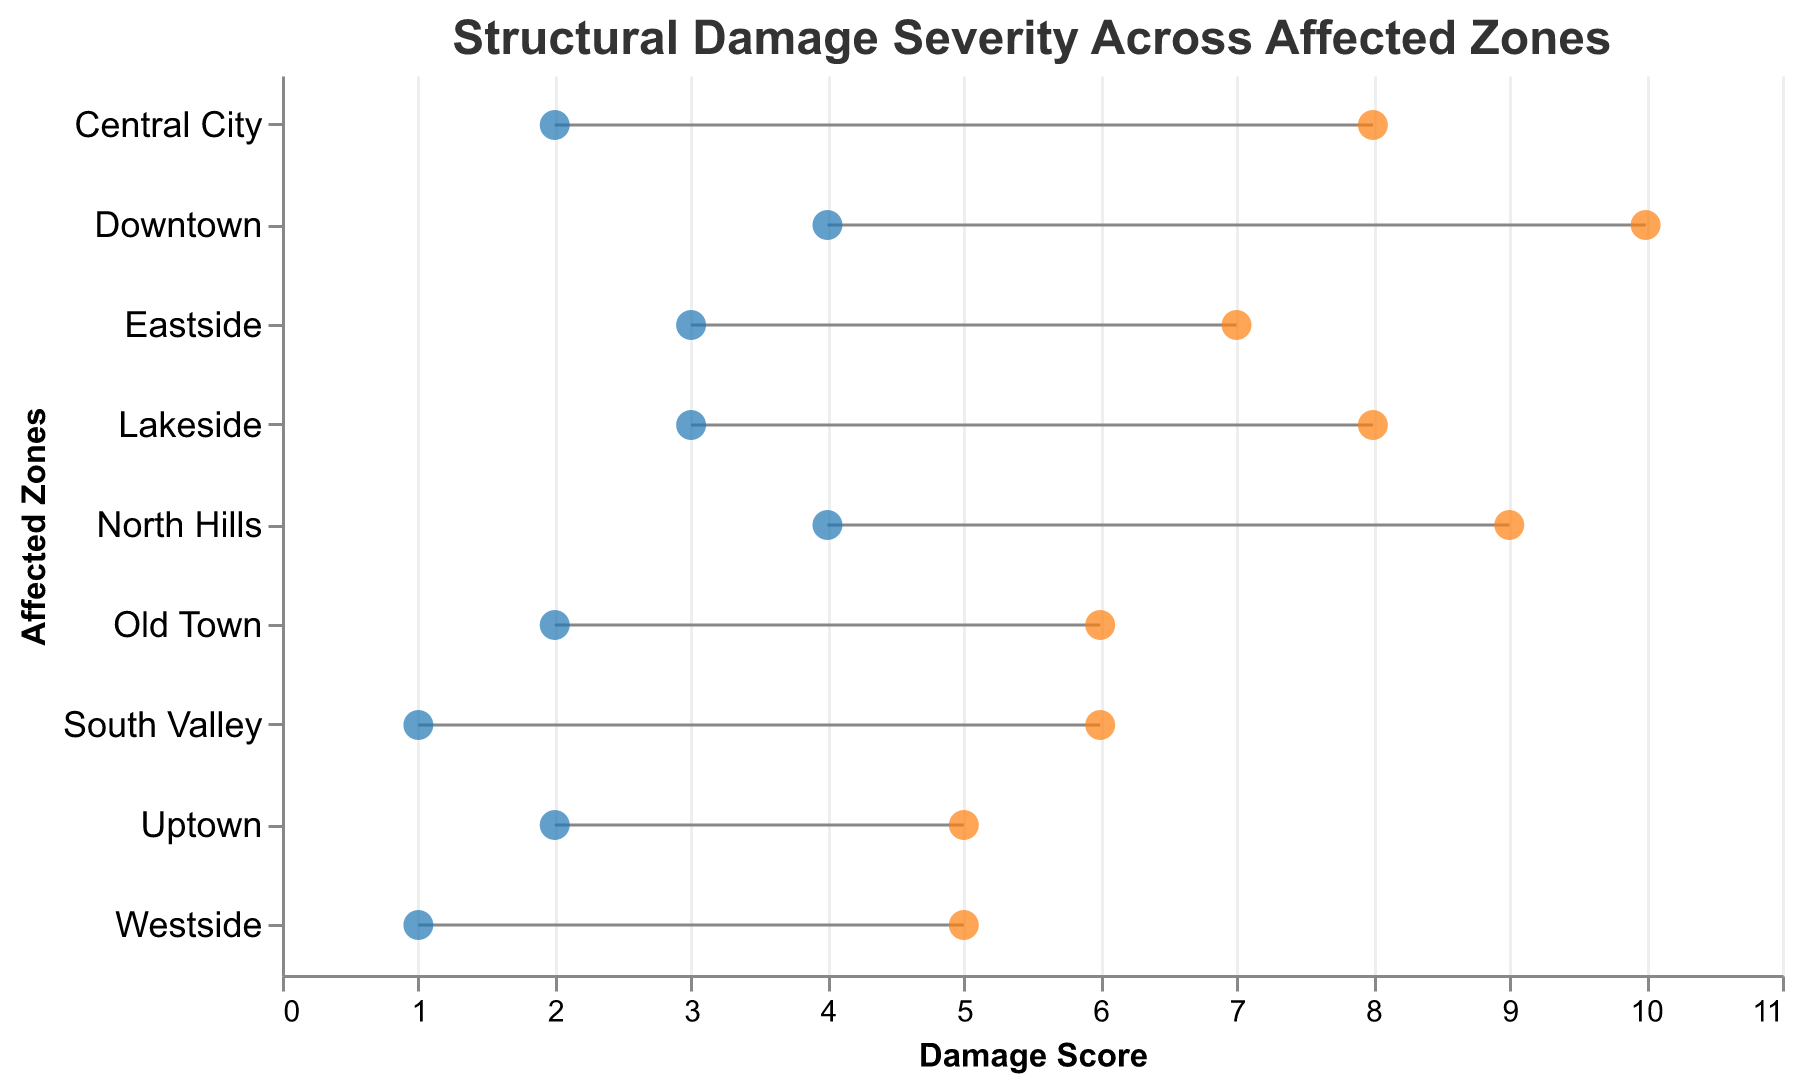How many affected zones are displayed in the plot? The plot lists affected zones along the y-axis. Counting each distinct zone name gives the total number of zones.
Answer: 9 Which zone has the highest maximum damage score? The maximum damage scores are represented by the orange dots. By inspecting these, Downtown has the highest point at a damage score of 10.
Answer: Downtown What is the range of damage scores for Central City? The damage range for Central City is from the minimum damage score to the maximum damage score, found along the x-axis for Central City's row. The range is 2 to 8.
Answer: 2 to 8 What are the zones with a minimum damage score of 2? We check the blue dots along the x-axis for those at position 2 and read the corresponding zones on the y-axis. The zones are Central City, Uptown, and Old Town.
Answer: Central City, Uptown, Old Town Which zone has the smallest range of damage scores? The smallest range is determined by finding the difference between the maximum and minimum damage scores for each zone and picking the zone with the smallest difference. The range for Uptown is from 2 to 5, resulting in the smallest range of 3.
Answer: Uptown Is any zone's minimum damage score greater than 3? Which one? The blue dots representing minimum damage scores greater than 3 can be checked; North Hills and Downtown both have minimum scores of 4 or higher.
Answer: North Hills, Downtown What is the average maximum damage score for Westside and South Valley combined? Adding the maximum damage scores for Westside (5) and South Valley (6), then dividing by 2, gives (5 + 6) / 2 = 5.5.
Answer: 5.5 Which zone has the largest gap between its minimum and maximum damage scores? By calculating the difference between the maximum and minimum damage scores for all zones and comparing them, Downtown has the largest gap, from 4 to 10, a difference of 6.
Answer: Downtown What’s the median value of maximum damage scores across all zones? Sorting the maximum damage scores (5, 5, 6, 7, 8, 8, 8, 9, 10) and finding the middle value gives the median as 8.
Answer: 8 